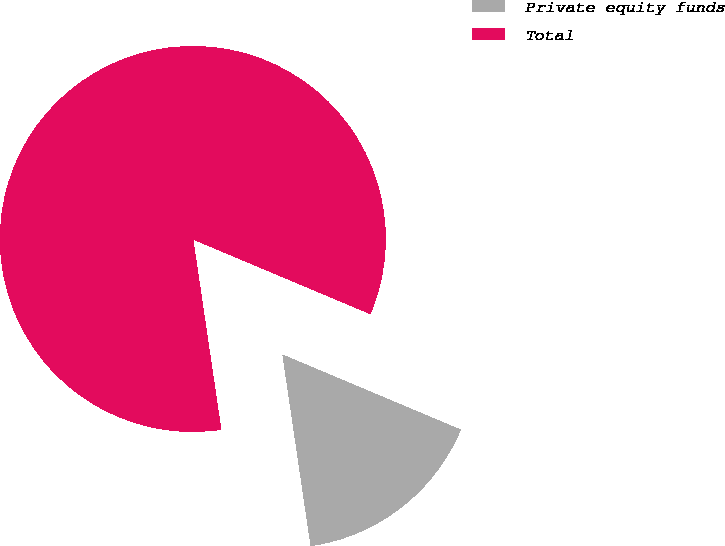Convert chart. <chart><loc_0><loc_0><loc_500><loc_500><pie_chart><fcel>Private equity funds<fcel>Total<nl><fcel>16.33%<fcel>83.67%<nl></chart> 